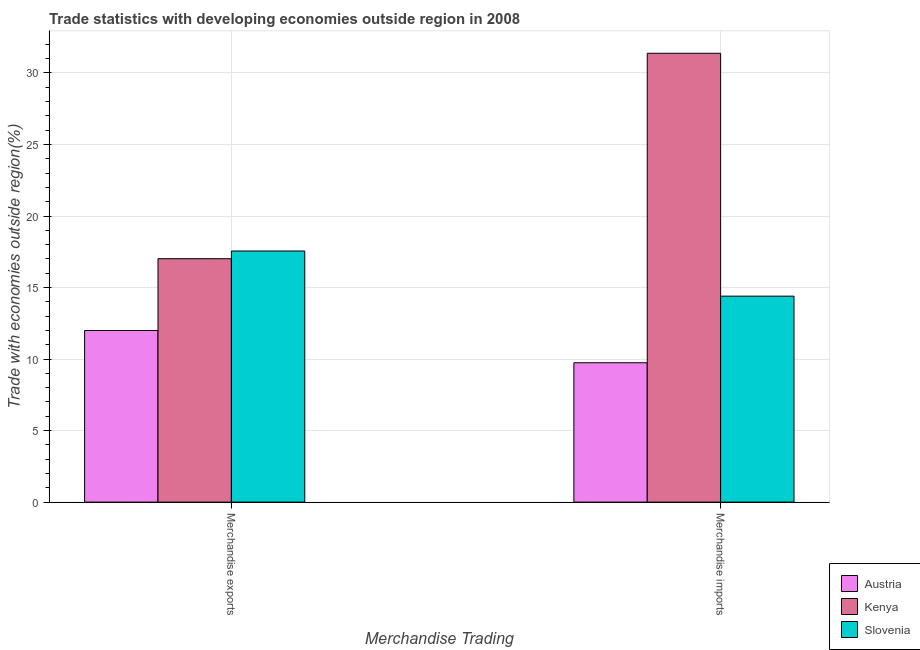How many different coloured bars are there?
Offer a terse response. 3. Are the number of bars on each tick of the X-axis equal?
Your answer should be very brief. Yes. How many bars are there on the 2nd tick from the left?
Offer a very short reply. 3. What is the label of the 2nd group of bars from the left?
Provide a short and direct response. Merchandise imports. What is the merchandise imports in Austria?
Provide a short and direct response. 9.74. Across all countries, what is the maximum merchandise imports?
Your answer should be compact. 31.38. Across all countries, what is the minimum merchandise exports?
Offer a very short reply. 12. In which country was the merchandise imports maximum?
Provide a succinct answer. Kenya. In which country was the merchandise exports minimum?
Your answer should be very brief. Austria. What is the total merchandise exports in the graph?
Provide a short and direct response. 46.57. What is the difference between the merchandise exports in Kenya and that in Austria?
Your answer should be very brief. 5.02. What is the difference between the merchandise exports in Austria and the merchandise imports in Slovenia?
Offer a very short reply. -2.4. What is the average merchandise imports per country?
Keep it short and to the point. 18.51. What is the difference between the merchandise imports and merchandise exports in Kenya?
Your answer should be very brief. 14.36. What is the ratio of the merchandise imports in Kenya to that in Austria?
Your answer should be compact. 3.22. What does the 1st bar from the left in Merchandise exports represents?
Ensure brevity in your answer.  Austria. What does the 1st bar from the right in Merchandise imports represents?
Ensure brevity in your answer.  Slovenia. How many bars are there?
Provide a succinct answer. 6. Does the graph contain grids?
Provide a short and direct response. Yes. Where does the legend appear in the graph?
Your answer should be compact. Bottom right. How are the legend labels stacked?
Make the answer very short. Vertical. What is the title of the graph?
Your response must be concise. Trade statistics with developing economies outside region in 2008. Does "Latin America(developing only)" appear as one of the legend labels in the graph?
Ensure brevity in your answer.  No. What is the label or title of the X-axis?
Your response must be concise. Merchandise Trading. What is the label or title of the Y-axis?
Provide a short and direct response. Trade with economies outside region(%). What is the Trade with economies outside region(%) of Austria in Merchandise exports?
Your answer should be very brief. 12. What is the Trade with economies outside region(%) in Kenya in Merchandise exports?
Your response must be concise. 17.02. What is the Trade with economies outside region(%) of Slovenia in Merchandise exports?
Make the answer very short. 17.55. What is the Trade with economies outside region(%) of Austria in Merchandise imports?
Offer a very short reply. 9.74. What is the Trade with economies outside region(%) of Kenya in Merchandise imports?
Your response must be concise. 31.38. What is the Trade with economies outside region(%) of Slovenia in Merchandise imports?
Your response must be concise. 14.4. Across all Merchandise Trading, what is the maximum Trade with economies outside region(%) of Austria?
Provide a succinct answer. 12. Across all Merchandise Trading, what is the maximum Trade with economies outside region(%) in Kenya?
Keep it short and to the point. 31.38. Across all Merchandise Trading, what is the maximum Trade with economies outside region(%) in Slovenia?
Offer a terse response. 17.55. Across all Merchandise Trading, what is the minimum Trade with economies outside region(%) in Austria?
Keep it short and to the point. 9.74. Across all Merchandise Trading, what is the minimum Trade with economies outside region(%) in Kenya?
Ensure brevity in your answer.  17.02. Across all Merchandise Trading, what is the minimum Trade with economies outside region(%) of Slovenia?
Give a very brief answer. 14.4. What is the total Trade with economies outside region(%) in Austria in the graph?
Provide a succinct answer. 21.74. What is the total Trade with economies outside region(%) in Kenya in the graph?
Ensure brevity in your answer.  48.39. What is the total Trade with economies outside region(%) in Slovenia in the graph?
Provide a short and direct response. 31.95. What is the difference between the Trade with economies outside region(%) of Austria in Merchandise exports and that in Merchandise imports?
Keep it short and to the point. 2.25. What is the difference between the Trade with economies outside region(%) of Kenya in Merchandise exports and that in Merchandise imports?
Offer a terse response. -14.36. What is the difference between the Trade with economies outside region(%) in Slovenia in Merchandise exports and that in Merchandise imports?
Give a very brief answer. 3.16. What is the difference between the Trade with economies outside region(%) of Austria in Merchandise exports and the Trade with economies outside region(%) of Kenya in Merchandise imports?
Offer a terse response. -19.38. What is the difference between the Trade with economies outside region(%) in Austria in Merchandise exports and the Trade with economies outside region(%) in Slovenia in Merchandise imports?
Ensure brevity in your answer.  -2.4. What is the difference between the Trade with economies outside region(%) of Kenya in Merchandise exports and the Trade with economies outside region(%) of Slovenia in Merchandise imports?
Give a very brief answer. 2.62. What is the average Trade with economies outside region(%) in Austria per Merchandise Trading?
Offer a very short reply. 10.87. What is the average Trade with economies outside region(%) of Kenya per Merchandise Trading?
Your answer should be very brief. 24.2. What is the average Trade with economies outside region(%) in Slovenia per Merchandise Trading?
Your answer should be compact. 15.98. What is the difference between the Trade with economies outside region(%) of Austria and Trade with economies outside region(%) of Kenya in Merchandise exports?
Offer a very short reply. -5.02. What is the difference between the Trade with economies outside region(%) of Austria and Trade with economies outside region(%) of Slovenia in Merchandise exports?
Provide a succinct answer. -5.56. What is the difference between the Trade with economies outside region(%) in Kenya and Trade with economies outside region(%) in Slovenia in Merchandise exports?
Your answer should be very brief. -0.54. What is the difference between the Trade with economies outside region(%) in Austria and Trade with economies outside region(%) in Kenya in Merchandise imports?
Offer a terse response. -21.63. What is the difference between the Trade with economies outside region(%) in Austria and Trade with economies outside region(%) in Slovenia in Merchandise imports?
Make the answer very short. -4.66. What is the difference between the Trade with economies outside region(%) in Kenya and Trade with economies outside region(%) in Slovenia in Merchandise imports?
Give a very brief answer. 16.98. What is the ratio of the Trade with economies outside region(%) of Austria in Merchandise exports to that in Merchandise imports?
Keep it short and to the point. 1.23. What is the ratio of the Trade with economies outside region(%) of Kenya in Merchandise exports to that in Merchandise imports?
Keep it short and to the point. 0.54. What is the ratio of the Trade with economies outside region(%) in Slovenia in Merchandise exports to that in Merchandise imports?
Keep it short and to the point. 1.22. What is the difference between the highest and the second highest Trade with economies outside region(%) in Austria?
Ensure brevity in your answer.  2.25. What is the difference between the highest and the second highest Trade with economies outside region(%) in Kenya?
Offer a terse response. 14.36. What is the difference between the highest and the second highest Trade with economies outside region(%) in Slovenia?
Provide a short and direct response. 3.16. What is the difference between the highest and the lowest Trade with economies outside region(%) in Austria?
Offer a very short reply. 2.25. What is the difference between the highest and the lowest Trade with economies outside region(%) of Kenya?
Your response must be concise. 14.36. What is the difference between the highest and the lowest Trade with economies outside region(%) in Slovenia?
Provide a succinct answer. 3.16. 